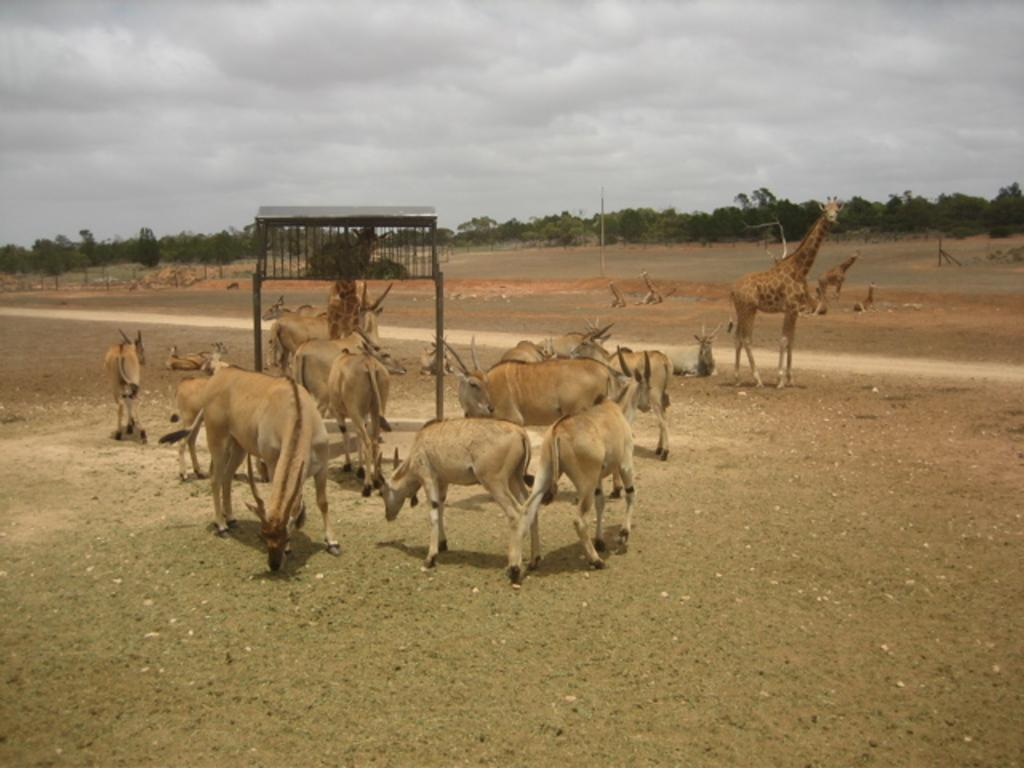What is located in the center of the image? There are animals standing in the center of the image. What can be seen in the background of the image? There are trees in the background of the image. What is in the center of the image besides the animals? There is a stand in the center of the image. How would you describe the weather based on the image? The sky is cloudy, which suggests a potentially overcast or rainy day. What type of ant is conducting a test for the company in the image? There are no ants, tests, or companies present in the image. What type of company is represented by the animals in the image? The image does not depict any companies or their representation; it simply shows animals standing in the center of the image. 